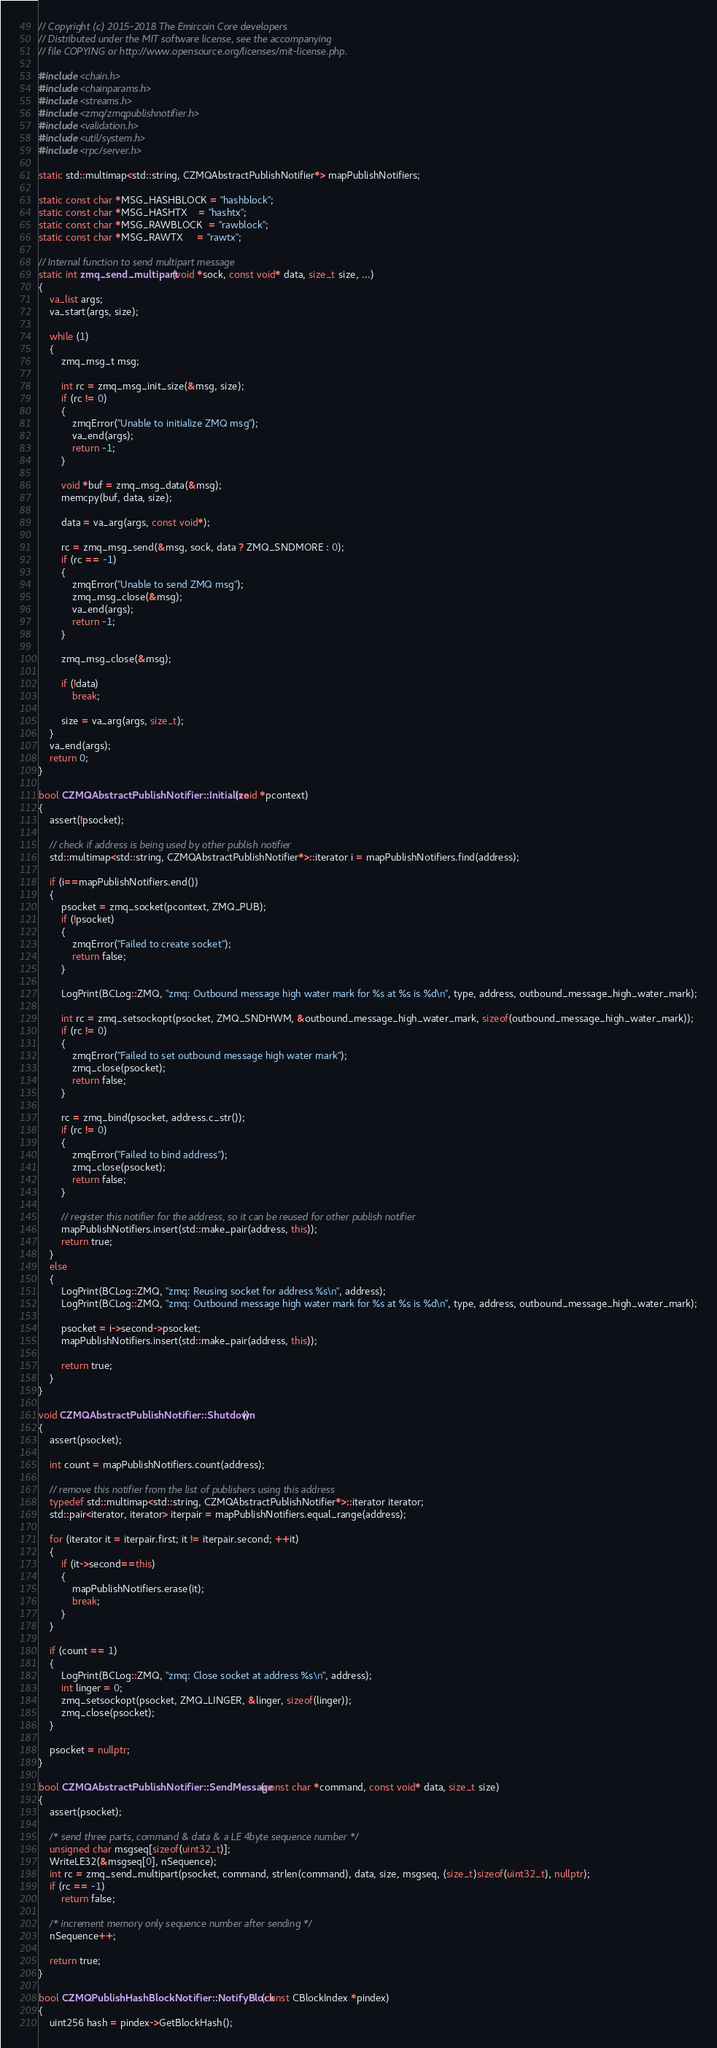Convert code to text. <code><loc_0><loc_0><loc_500><loc_500><_C++_>// Copyright (c) 2015-2018 The Emircoin Core developers
// Distributed under the MIT software license, see the accompanying
// file COPYING or http://www.opensource.org/licenses/mit-license.php.

#include <chain.h>
#include <chainparams.h>
#include <streams.h>
#include <zmq/zmqpublishnotifier.h>
#include <validation.h>
#include <util/system.h>
#include <rpc/server.h>

static std::multimap<std::string, CZMQAbstractPublishNotifier*> mapPublishNotifiers;

static const char *MSG_HASHBLOCK = "hashblock";
static const char *MSG_HASHTX    = "hashtx";
static const char *MSG_RAWBLOCK  = "rawblock";
static const char *MSG_RAWTX     = "rawtx";

// Internal function to send multipart message
static int zmq_send_multipart(void *sock, const void* data, size_t size, ...)
{
    va_list args;
    va_start(args, size);

    while (1)
    {
        zmq_msg_t msg;

        int rc = zmq_msg_init_size(&msg, size);
        if (rc != 0)
        {
            zmqError("Unable to initialize ZMQ msg");
            va_end(args);
            return -1;
        }

        void *buf = zmq_msg_data(&msg);
        memcpy(buf, data, size);

        data = va_arg(args, const void*);

        rc = zmq_msg_send(&msg, sock, data ? ZMQ_SNDMORE : 0);
        if (rc == -1)
        {
            zmqError("Unable to send ZMQ msg");
            zmq_msg_close(&msg);
            va_end(args);
            return -1;
        }

        zmq_msg_close(&msg);

        if (!data)
            break;

        size = va_arg(args, size_t);
    }
    va_end(args);
    return 0;
}

bool CZMQAbstractPublishNotifier::Initialize(void *pcontext)
{
    assert(!psocket);

    // check if address is being used by other publish notifier
    std::multimap<std::string, CZMQAbstractPublishNotifier*>::iterator i = mapPublishNotifiers.find(address);

    if (i==mapPublishNotifiers.end())
    {
        psocket = zmq_socket(pcontext, ZMQ_PUB);
        if (!psocket)
        {
            zmqError("Failed to create socket");
            return false;
        }

        LogPrint(BCLog::ZMQ, "zmq: Outbound message high water mark for %s at %s is %d\n", type, address, outbound_message_high_water_mark);

        int rc = zmq_setsockopt(psocket, ZMQ_SNDHWM, &outbound_message_high_water_mark, sizeof(outbound_message_high_water_mark));
        if (rc != 0)
        {
            zmqError("Failed to set outbound message high water mark");
            zmq_close(psocket);
            return false;
        }

        rc = zmq_bind(psocket, address.c_str());
        if (rc != 0)
        {
            zmqError("Failed to bind address");
            zmq_close(psocket);
            return false;
        }

        // register this notifier for the address, so it can be reused for other publish notifier
        mapPublishNotifiers.insert(std::make_pair(address, this));
        return true;
    }
    else
    {
        LogPrint(BCLog::ZMQ, "zmq: Reusing socket for address %s\n", address);
        LogPrint(BCLog::ZMQ, "zmq: Outbound message high water mark for %s at %s is %d\n", type, address, outbound_message_high_water_mark);

        psocket = i->second->psocket;
        mapPublishNotifiers.insert(std::make_pair(address, this));

        return true;
    }
}

void CZMQAbstractPublishNotifier::Shutdown()
{
    assert(psocket);

    int count = mapPublishNotifiers.count(address);

    // remove this notifier from the list of publishers using this address
    typedef std::multimap<std::string, CZMQAbstractPublishNotifier*>::iterator iterator;
    std::pair<iterator, iterator> iterpair = mapPublishNotifiers.equal_range(address);

    for (iterator it = iterpair.first; it != iterpair.second; ++it)
    {
        if (it->second==this)
        {
            mapPublishNotifiers.erase(it);
            break;
        }
    }

    if (count == 1)
    {
        LogPrint(BCLog::ZMQ, "zmq: Close socket at address %s\n", address);
        int linger = 0;
        zmq_setsockopt(psocket, ZMQ_LINGER, &linger, sizeof(linger));
        zmq_close(psocket);
    }

    psocket = nullptr;
}

bool CZMQAbstractPublishNotifier::SendMessage(const char *command, const void* data, size_t size)
{
    assert(psocket);

    /* send three parts, command & data & a LE 4byte sequence number */
    unsigned char msgseq[sizeof(uint32_t)];
    WriteLE32(&msgseq[0], nSequence);
    int rc = zmq_send_multipart(psocket, command, strlen(command), data, size, msgseq, (size_t)sizeof(uint32_t), nullptr);
    if (rc == -1)
        return false;

    /* increment memory only sequence number after sending */
    nSequence++;

    return true;
}

bool CZMQPublishHashBlockNotifier::NotifyBlock(const CBlockIndex *pindex)
{
    uint256 hash = pindex->GetBlockHash();</code> 